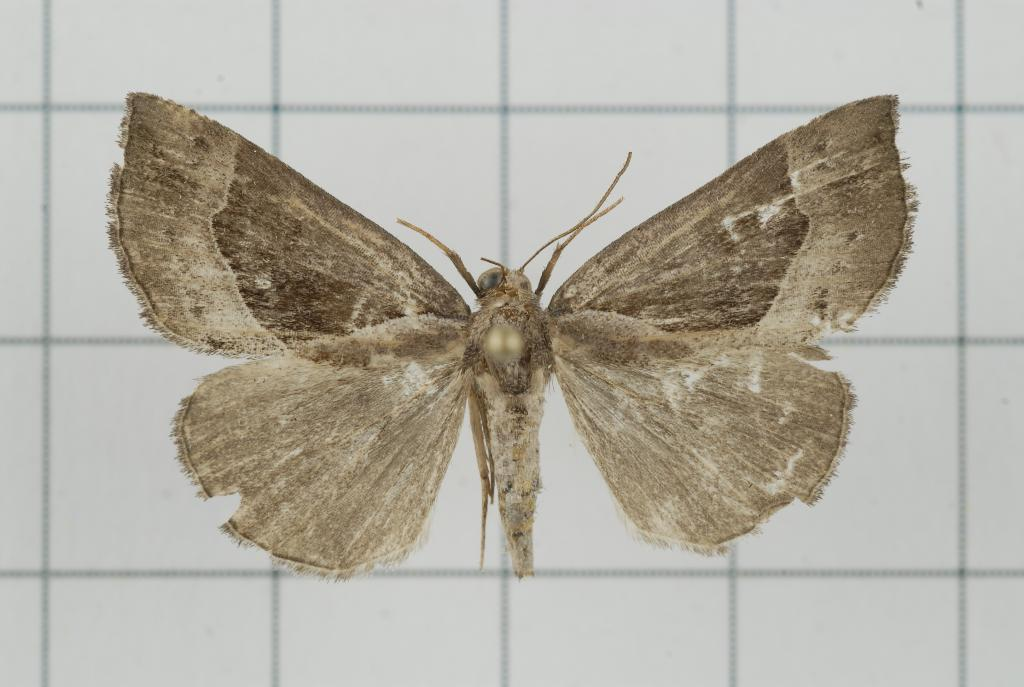What is the main subject of the image? There is a butterfly in the image. Where is the butterfly located? The butterfly is on the white floor. What type of voice can be heard coming from the butterfly in the image? Butterflies do not have voices, so there is no voice coming from the butterfly in the image. 